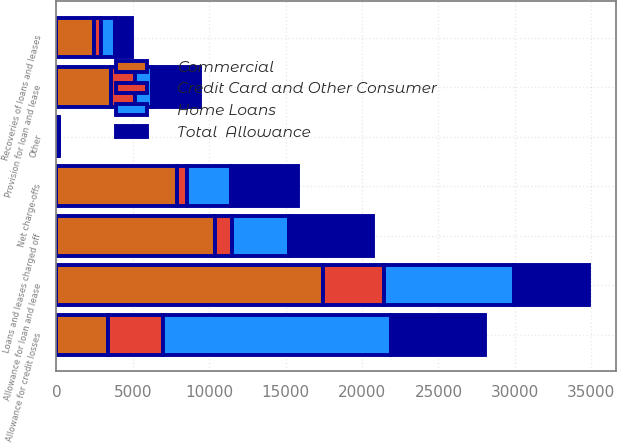<chart> <loc_0><loc_0><loc_500><loc_500><stacked_bar_chart><ecel><fcel>Allowance for loan and lease<fcel>Loans and leases charged off<fcel>Recoveries of loans and leases<fcel>Net charge-offs<fcel>Provision for loan and lease<fcel>Other<fcel>Allowance for credit losses<nl><fcel>Home Loans<fcel>8518<fcel>3766<fcel>879<fcel>2887<fcel>1124<fcel>68<fcel>14933<nl><fcel>Total  Allowance<fcel>4905<fcel>5495<fcel>1141<fcel>4354<fcel>3139<fcel>20<fcel>6140<nl><fcel>Credit Card and Other Consumer<fcel>4005<fcel>1108<fcel>452<fcel>656<fcel>1559<fcel>4<fcel>3619<nl><fcel>Commercial<fcel>17428<fcel>10369<fcel>2472<fcel>7897<fcel>3574<fcel>92<fcel>3356.5<nl></chart> 